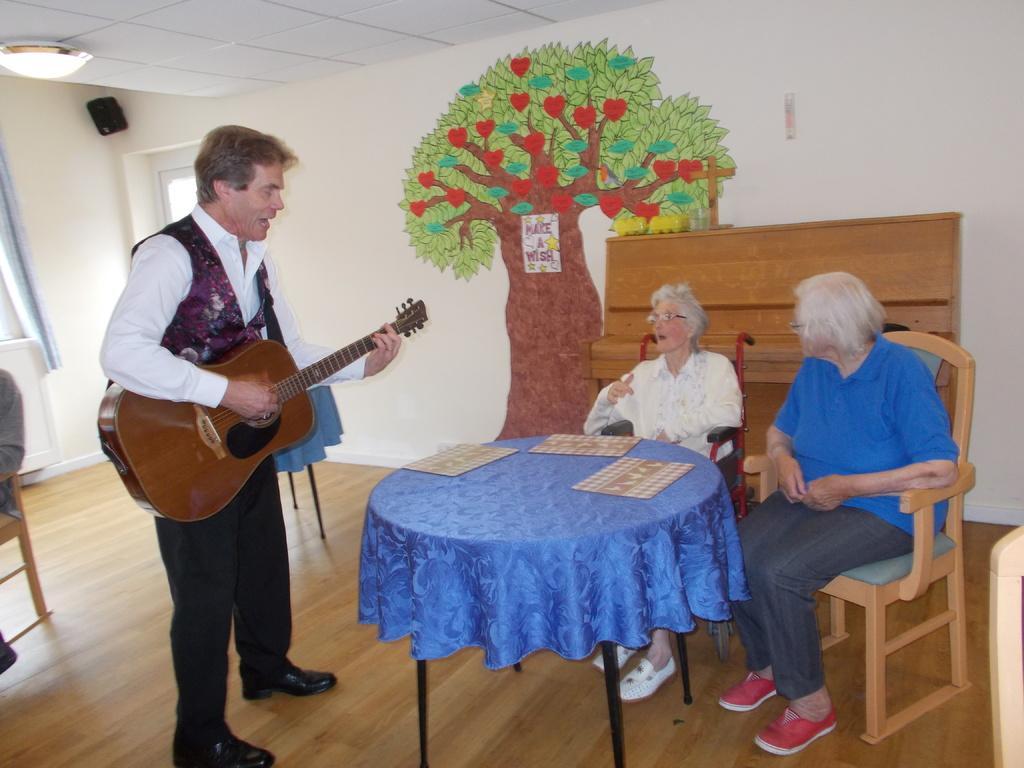Could you give a brief overview of what you see in this image? there are two all people sitting in a chair in front of a table behind them there is a man standing holding a guitar and there is a art on the wall of a tree. 